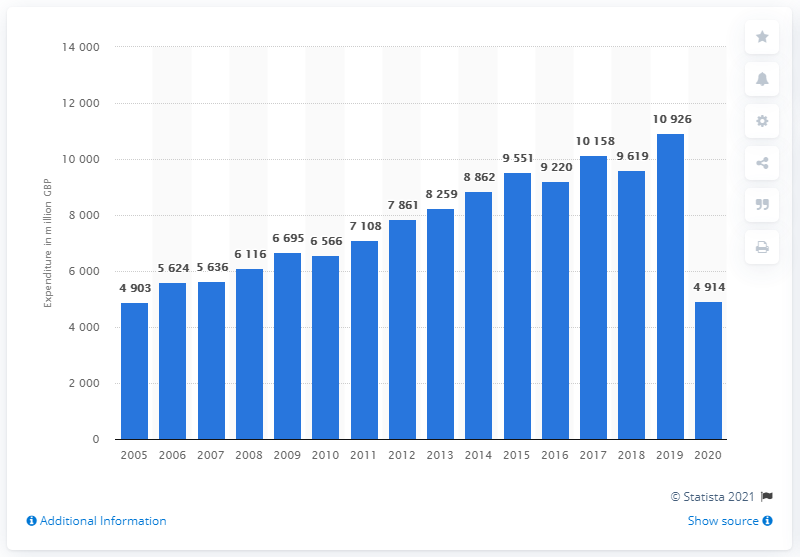Give some essential details in this illustration. In the United Kingdom in 2019, the worth of footwear was 10,926 GBP. In the year 2020, footwear expenditure in the UK decreased by 10.9 billion pounds. In the year 2005, footwear spending in the UK began to increase, marking a significant shift in consumer behavior. 